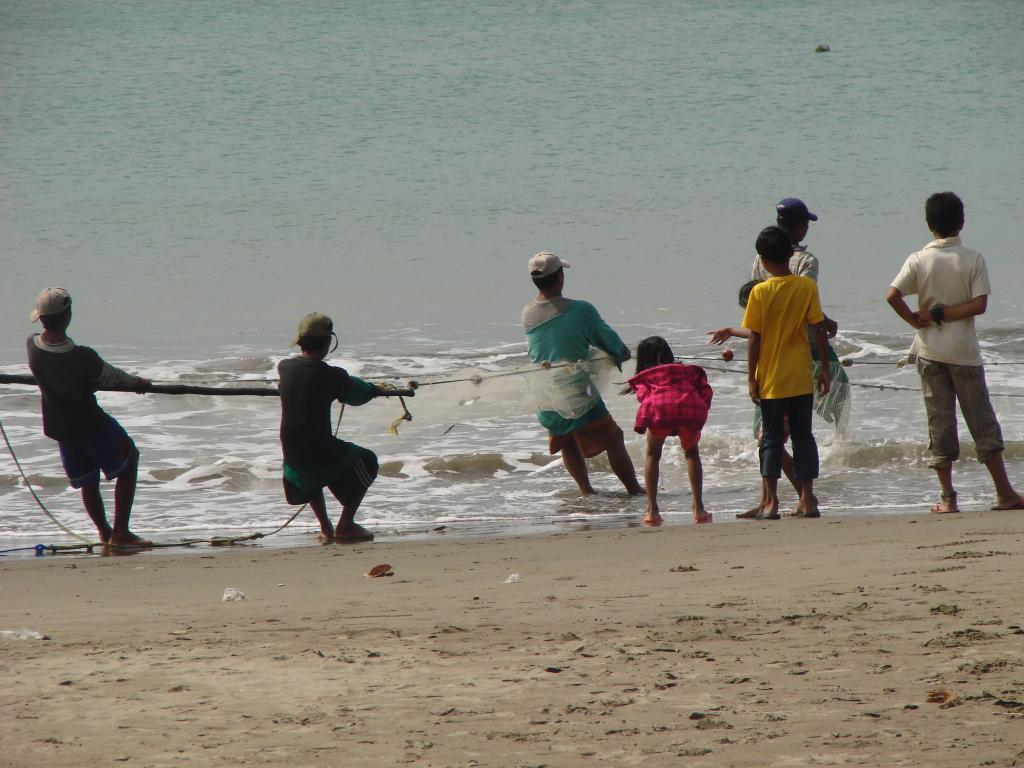Who is present in the image? There are people in the image. What are the people doing in the image? The people are catching fishes in a net. What type of surface is at the bottom of the image? There is sand at the bottom of the image. What natural element is visible in the image? Water is visible in the image. Where might this image have been taken? The image appears to be taken near the ocean. What type of doll can be seen laughing near the iron in the image? There is no doll or iron present in the image; it features people catching fishes near the ocean. 